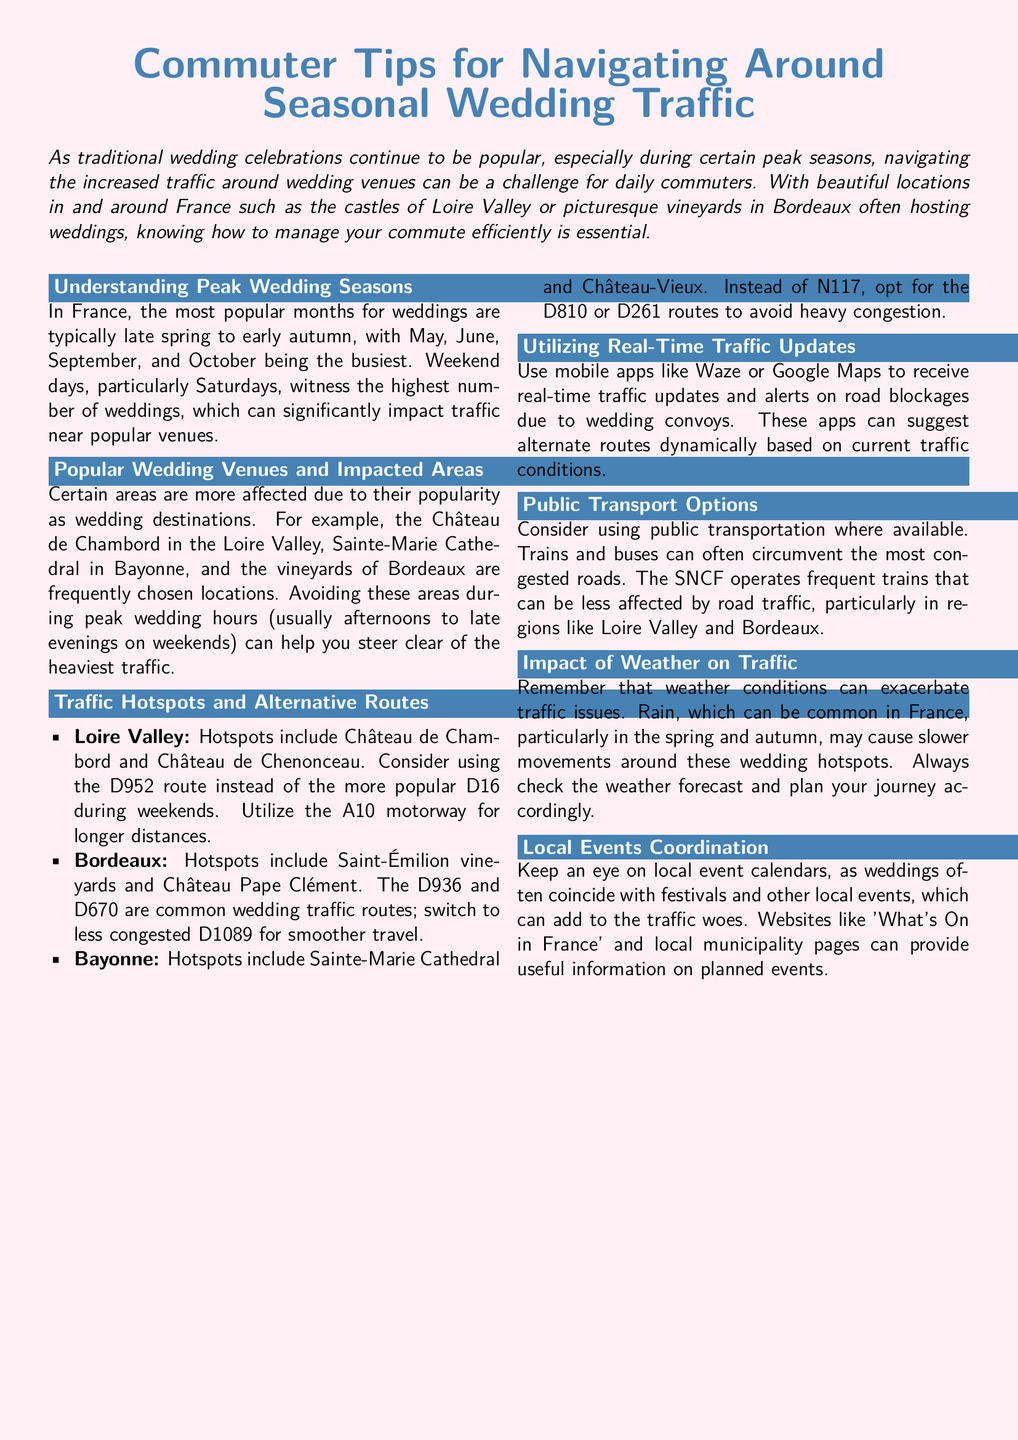What are the peak months for weddings in France? The document states that the busiest months for weddings in France are May, June, September, and October.
Answer: May, June, September, October Which château is mentioned as a hotspot in the Loire Valley? The document lists Château de Chambord and Château de Chenonceau as hotspots in the Loire Valley.
Answer: Château de Chambord What specific routes are recommended to avoid traffic in Bordeaux? The document suggests switching to the D1089 route in Bordeaux to avoid traffic instead of the D936 and D670.
Answer: D1089 What mobile apps are suggested for real-time traffic updates? The document mentions Waze and Google Maps as useful mobile apps for real-time traffic information.
Answer: Waze, Google Maps What time of day is wedding traffic typically heaviest on weekends? The document notes that wedding traffic is heaviest in the afternoons to late evenings on weekends.
Answer: Afternoons to late evenings What should commuters check to plan their journey effectively? The document advises commuters to check the weather forecast before planning their journeys, especially during wedding seasons.
Answer: Weather forecast What is the impact of local events on wedding traffic? The document explains that weddings often coincide with local festivals and events, which can exacerbate traffic issues.
Answer: Exacerbate traffic issues Which train service operates in regions like Loire Valley and Bordeaux? The document refers to the SNCF as the train service operating frequently in these regions.
Answer: SNCF 